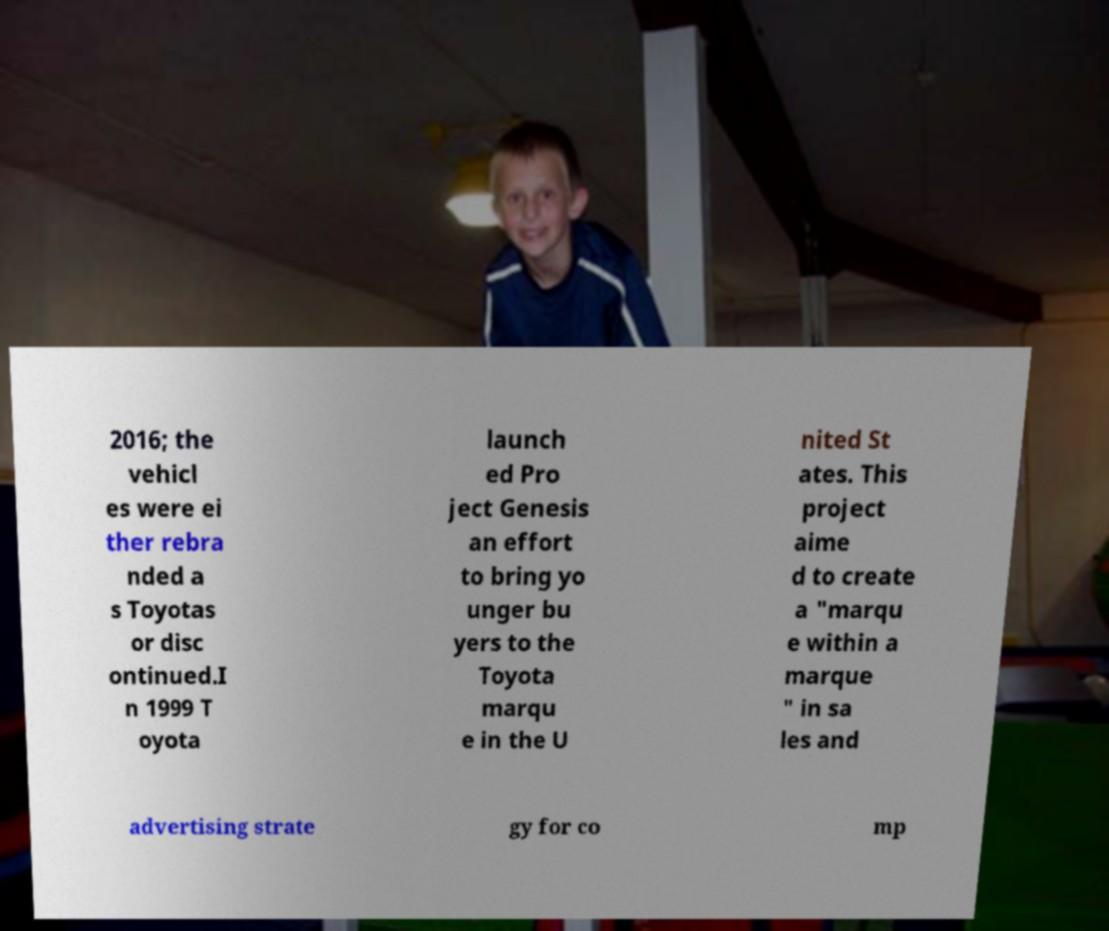Can you read and provide the text displayed in the image?This photo seems to have some interesting text. Can you extract and type it out for me? 2016; the vehicl es were ei ther rebra nded a s Toyotas or disc ontinued.I n 1999 T oyota launch ed Pro ject Genesis an effort to bring yo unger bu yers to the Toyota marqu e in the U nited St ates. This project aime d to create a "marqu e within a marque " in sa les and advertising strate gy for co mp 